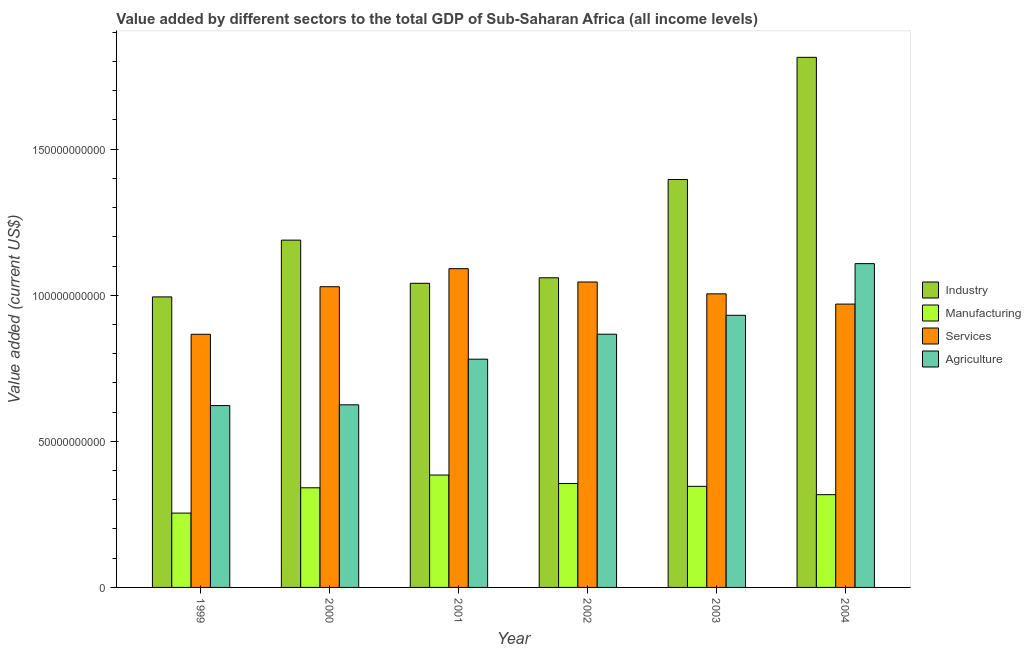How many groups of bars are there?
Your answer should be very brief. 6. Are the number of bars per tick equal to the number of legend labels?
Give a very brief answer. Yes. Are the number of bars on each tick of the X-axis equal?
Provide a succinct answer. Yes. How many bars are there on the 5th tick from the right?
Your answer should be very brief. 4. What is the value added by industrial sector in 1999?
Your response must be concise. 9.94e+1. Across all years, what is the maximum value added by manufacturing sector?
Provide a succinct answer. 3.85e+1. Across all years, what is the minimum value added by industrial sector?
Provide a succinct answer. 9.94e+1. What is the total value added by industrial sector in the graph?
Offer a terse response. 7.49e+11. What is the difference between the value added by services sector in 2000 and that in 2003?
Make the answer very short. 2.44e+09. What is the difference between the value added by services sector in 2002 and the value added by agricultural sector in 1999?
Provide a short and direct response. 1.79e+1. What is the average value added by manufacturing sector per year?
Provide a succinct answer. 3.33e+1. In the year 2004, what is the difference between the value added by agricultural sector and value added by industrial sector?
Offer a terse response. 0. What is the ratio of the value added by services sector in 2000 to that in 2001?
Offer a very short reply. 0.94. Is the difference between the value added by industrial sector in 1999 and 2001 greater than the difference between the value added by agricultural sector in 1999 and 2001?
Ensure brevity in your answer.  No. What is the difference between the highest and the second highest value added by services sector?
Your answer should be compact. 4.56e+09. What is the difference between the highest and the lowest value added by agricultural sector?
Your response must be concise. 4.86e+1. What does the 2nd bar from the left in 2004 represents?
Your response must be concise. Manufacturing. What does the 2nd bar from the right in 2004 represents?
Give a very brief answer. Services. How many bars are there?
Offer a very short reply. 24. How many years are there in the graph?
Make the answer very short. 6. What is the difference between two consecutive major ticks on the Y-axis?
Your answer should be compact. 5.00e+1. Does the graph contain any zero values?
Provide a short and direct response. No. Does the graph contain grids?
Offer a very short reply. No. What is the title of the graph?
Your answer should be compact. Value added by different sectors to the total GDP of Sub-Saharan Africa (all income levels). Does "Overall level" appear as one of the legend labels in the graph?
Provide a succinct answer. No. What is the label or title of the Y-axis?
Provide a succinct answer. Value added (current US$). What is the Value added (current US$) in Industry in 1999?
Your answer should be compact. 9.94e+1. What is the Value added (current US$) of Manufacturing in 1999?
Your response must be concise. 2.54e+1. What is the Value added (current US$) of Services in 1999?
Keep it short and to the point. 8.66e+1. What is the Value added (current US$) in Agriculture in 1999?
Ensure brevity in your answer.  6.22e+1. What is the Value added (current US$) in Industry in 2000?
Your answer should be compact. 1.19e+11. What is the Value added (current US$) of Manufacturing in 2000?
Ensure brevity in your answer.  3.41e+1. What is the Value added (current US$) of Services in 2000?
Keep it short and to the point. 1.03e+11. What is the Value added (current US$) of Agriculture in 2000?
Your answer should be very brief. 6.25e+1. What is the Value added (current US$) of Industry in 2001?
Your answer should be very brief. 1.04e+11. What is the Value added (current US$) of Manufacturing in 2001?
Your answer should be compact. 3.85e+1. What is the Value added (current US$) of Services in 2001?
Your answer should be very brief. 1.09e+11. What is the Value added (current US$) in Agriculture in 2001?
Give a very brief answer. 7.81e+1. What is the Value added (current US$) of Industry in 2002?
Make the answer very short. 1.06e+11. What is the Value added (current US$) of Manufacturing in 2002?
Offer a terse response. 3.56e+1. What is the Value added (current US$) in Services in 2002?
Ensure brevity in your answer.  1.05e+11. What is the Value added (current US$) in Agriculture in 2002?
Offer a very short reply. 8.67e+1. What is the Value added (current US$) of Industry in 2003?
Provide a short and direct response. 1.40e+11. What is the Value added (current US$) of Manufacturing in 2003?
Provide a short and direct response. 3.46e+1. What is the Value added (current US$) in Services in 2003?
Provide a succinct answer. 1.00e+11. What is the Value added (current US$) of Agriculture in 2003?
Make the answer very short. 9.31e+1. What is the Value added (current US$) in Industry in 2004?
Your answer should be very brief. 1.81e+11. What is the Value added (current US$) in Manufacturing in 2004?
Ensure brevity in your answer.  3.17e+1. What is the Value added (current US$) of Services in 2004?
Provide a short and direct response. 9.70e+1. What is the Value added (current US$) of Agriculture in 2004?
Provide a short and direct response. 1.11e+11. Across all years, what is the maximum Value added (current US$) in Industry?
Keep it short and to the point. 1.81e+11. Across all years, what is the maximum Value added (current US$) of Manufacturing?
Make the answer very short. 3.85e+1. Across all years, what is the maximum Value added (current US$) of Services?
Your answer should be very brief. 1.09e+11. Across all years, what is the maximum Value added (current US$) in Agriculture?
Your answer should be very brief. 1.11e+11. Across all years, what is the minimum Value added (current US$) of Industry?
Your answer should be compact. 9.94e+1. Across all years, what is the minimum Value added (current US$) in Manufacturing?
Your response must be concise. 2.54e+1. Across all years, what is the minimum Value added (current US$) in Services?
Offer a very short reply. 8.66e+1. Across all years, what is the minimum Value added (current US$) in Agriculture?
Provide a short and direct response. 6.22e+1. What is the total Value added (current US$) in Industry in the graph?
Offer a very short reply. 7.49e+11. What is the total Value added (current US$) of Manufacturing in the graph?
Offer a very short reply. 2.00e+11. What is the total Value added (current US$) in Services in the graph?
Make the answer very short. 6.01e+11. What is the total Value added (current US$) in Agriculture in the graph?
Give a very brief answer. 4.93e+11. What is the difference between the Value added (current US$) of Industry in 1999 and that in 2000?
Offer a very short reply. -1.94e+1. What is the difference between the Value added (current US$) of Manufacturing in 1999 and that in 2000?
Provide a short and direct response. -8.67e+09. What is the difference between the Value added (current US$) in Services in 1999 and that in 2000?
Keep it short and to the point. -1.63e+1. What is the difference between the Value added (current US$) in Agriculture in 1999 and that in 2000?
Provide a succinct answer. -2.59e+08. What is the difference between the Value added (current US$) in Industry in 1999 and that in 2001?
Your response must be concise. -4.66e+09. What is the difference between the Value added (current US$) in Manufacturing in 1999 and that in 2001?
Keep it short and to the point. -1.30e+1. What is the difference between the Value added (current US$) of Services in 1999 and that in 2001?
Offer a terse response. -2.25e+1. What is the difference between the Value added (current US$) in Agriculture in 1999 and that in 2001?
Your answer should be compact. -1.59e+1. What is the difference between the Value added (current US$) of Industry in 1999 and that in 2002?
Your answer should be very brief. -6.55e+09. What is the difference between the Value added (current US$) in Manufacturing in 1999 and that in 2002?
Your response must be concise. -1.01e+1. What is the difference between the Value added (current US$) in Services in 1999 and that in 2002?
Provide a succinct answer. -1.79e+1. What is the difference between the Value added (current US$) of Agriculture in 1999 and that in 2002?
Your answer should be very brief. -2.44e+1. What is the difference between the Value added (current US$) in Industry in 1999 and that in 2003?
Provide a succinct answer. -4.02e+1. What is the difference between the Value added (current US$) of Manufacturing in 1999 and that in 2003?
Provide a short and direct response. -9.15e+09. What is the difference between the Value added (current US$) in Services in 1999 and that in 2003?
Offer a terse response. -1.38e+1. What is the difference between the Value added (current US$) of Agriculture in 1999 and that in 2003?
Ensure brevity in your answer.  -3.09e+1. What is the difference between the Value added (current US$) in Industry in 1999 and that in 2004?
Offer a terse response. -8.20e+1. What is the difference between the Value added (current US$) in Manufacturing in 1999 and that in 2004?
Provide a short and direct response. -6.31e+09. What is the difference between the Value added (current US$) of Services in 1999 and that in 2004?
Ensure brevity in your answer.  -1.03e+1. What is the difference between the Value added (current US$) in Agriculture in 1999 and that in 2004?
Offer a very short reply. -4.86e+1. What is the difference between the Value added (current US$) of Industry in 2000 and that in 2001?
Make the answer very short. 1.48e+1. What is the difference between the Value added (current US$) in Manufacturing in 2000 and that in 2001?
Provide a succinct answer. -4.36e+09. What is the difference between the Value added (current US$) of Services in 2000 and that in 2001?
Your answer should be compact. -6.18e+09. What is the difference between the Value added (current US$) of Agriculture in 2000 and that in 2001?
Ensure brevity in your answer.  -1.56e+1. What is the difference between the Value added (current US$) of Industry in 2000 and that in 2002?
Make the answer very short. 1.29e+1. What is the difference between the Value added (current US$) of Manufacturing in 2000 and that in 2002?
Provide a short and direct response. -1.48e+09. What is the difference between the Value added (current US$) in Services in 2000 and that in 2002?
Give a very brief answer. -1.62e+09. What is the difference between the Value added (current US$) in Agriculture in 2000 and that in 2002?
Your answer should be compact. -2.42e+1. What is the difference between the Value added (current US$) in Industry in 2000 and that in 2003?
Provide a short and direct response. -2.08e+1. What is the difference between the Value added (current US$) of Manufacturing in 2000 and that in 2003?
Offer a terse response. -4.88e+08. What is the difference between the Value added (current US$) in Services in 2000 and that in 2003?
Offer a terse response. 2.44e+09. What is the difference between the Value added (current US$) of Agriculture in 2000 and that in 2003?
Offer a very short reply. -3.06e+1. What is the difference between the Value added (current US$) in Industry in 2000 and that in 2004?
Your response must be concise. -6.26e+1. What is the difference between the Value added (current US$) in Manufacturing in 2000 and that in 2004?
Your answer should be very brief. 2.35e+09. What is the difference between the Value added (current US$) in Services in 2000 and that in 2004?
Keep it short and to the point. 5.94e+09. What is the difference between the Value added (current US$) in Agriculture in 2000 and that in 2004?
Your answer should be compact. -4.83e+1. What is the difference between the Value added (current US$) in Industry in 2001 and that in 2002?
Make the answer very short. -1.89e+09. What is the difference between the Value added (current US$) of Manufacturing in 2001 and that in 2002?
Your response must be concise. 2.88e+09. What is the difference between the Value added (current US$) of Services in 2001 and that in 2002?
Give a very brief answer. 4.56e+09. What is the difference between the Value added (current US$) of Agriculture in 2001 and that in 2002?
Offer a very short reply. -8.54e+09. What is the difference between the Value added (current US$) in Industry in 2001 and that in 2003?
Ensure brevity in your answer.  -3.55e+1. What is the difference between the Value added (current US$) in Manufacturing in 2001 and that in 2003?
Offer a very short reply. 3.87e+09. What is the difference between the Value added (current US$) in Services in 2001 and that in 2003?
Ensure brevity in your answer.  8.61e+09. What is the difference between the Value added (current US$) in Agriculture in 2001 and that in 2003?
Your response must be concise. -1.50e+1. What is the difference between the Value added (current US$) of Industry in 2001 and that in 2004?
Provide a succinct answer. -7.73e+1. What is the difference between the Value added (current US$) in Manufacturing in 2001 and that in 2004?
Provide a short and direct response. 6.71e+09. What is the difference between the Value added (current US$) in Services in 2001 and that in 2004?
Offer a very short reply. 1.21e+1. What is the difference between the Value added (current US$) in Agriculture in 2001 and that in 2004?
Your response must be concise. -3.27e+1. What is the difference between the Value added (current US$) in Industry in 2002 and that in 2003?
Ensure brevity in your answer.  -3.36e+1. What is the difference between the Value added (current US$) in Manufacturing in 2002 and that in 2003?
Your answer should be compact. 9.88e+08. What is the difference between the Value added (current US$) of Services in 2002 and that in 2003?
Your answer should be compact. 4.06e+09. What is the difference between the Value added (current US$) in Agriculture in 2002 and that in 2003?
Your response must be concise. -6.47e+09. What is the difference between the Value added (current US$) of Industry in 2002 and that in 2004?
Offer a very short reply. -7.54e+1. What is the difference between the Value added (current US$) in Manufacturing in 2002 and that in 2004?
Offer a very short reply. 3.83e+09. What is the difference between the Value added (current US$) of Services in 2002 and that in 2004?
Keep it short and to the point. 7.56e+09. What is the difference between the Value added (current US$) of Agriculture in 2002 and that in 2004?
Your answer should be very brief. -2.42e+1. What is the difference between the Value added (current US$) in Industry in 2003 and that in 2004?
Make the answer very short. -4.18e+1. What is the difference between the Value added (current US$) of Manufacturing in 2003 and that in 2004?
Your answer should be compact. 2.84e+09. What is the difference between the Value added (current US$) in Services in 2003 and that in 2004?
Your answer should be compact. 3.51e+09. What is the difference between the Value added (current US$) in Agriculture in 2003 and that in 2004?
Offer a very short reply. -1.77e+1. What is the difference between the Value added (current US$) in Industry in 1999 and the Value added (current US$) in Manufacturing in 2000?
Your answer should be compact. 6.53e+1. What is the difference between the Value added (current US$) of Industry in 1999 and the Value added (current US$) of Services in 2000?
Offer a very short reply. -3.48e+09. What is the difference between the Value added (current US$) of Industry in 1999 and the Value added (current US$) of Agriculture in 2000?
Provide a succinct answer. 3.69e+1. What is the difference between the Value added (current US$) in Manufacturing in 1999 and the Value added (current US$) in Services in 2000?
Give a very brief answer. -7.75e+1. What is the difference between the Value added (current US$) of Manufacturing in 1999 and the Value added (current US$) of Agriculture in 2000?
Your response must be concise. -3.71e+1. What is the difference between the Value added (current US$) in Services in 1999 and the Value added (current US$) in Agriculture in 2000?
Offer a terse response. 2.41e+1. What is the difference between the Value added (current US$) of Industry in 1999 and the Value added (current US$) of Manufacturing in 2001?
Give a very brief answer. 6.10e+1. What is the difference between the Value added (current US$) of Industry in 1999 and the Value added (current US$) of Services in 2001?
Provide a short and direct response. -9.66e+09. What is the difference between the Value added (current US$) in Industry in 1999 and the Value added (current US$) in Agriculture in 2001?
Keep it short and to the point. 2.13e+1. What is the difference between the Value added (current US$) of Manufacturing in 1999 and the Value added (current US$) of Services in 2001?
Offer a terse response. -8.37e+1. What is the difference between the Value added (current US$) of Manufacturing in 1999 and the Value added (current US$) of Agriculture in 2001?
Your response must be concise. -5.27e+1. What is the difference between the Value added (current US$) of Services in 1999 and the Value added (current US$) of Agriculture in 2001?
Provide a short and direct response. 8.51e+09. What is the difference between the Value added (current US$) of Industry in 1999 and the Value added (current US$) of Manufacturing in 2002?
Keep it short and to the point. 6.38e+1. What is the difference between the Value added (current US$) of Industry in 1999 and the Value added (current US$) of Services in 2002?
Ensure brevity in your answer.  -5.10e+09. What is the difference between the Value added (current US$) of Industry in 1999 and the Value added (current US$) of Agriculture in 2002?
Provide a short and direct response. 1.28e+1. What is the difference between the Value added (current US$) in Manufacturing in 1999 and the Value added (current US$) in Services in 2002?
Ensure brevity in your answer.  -7.91e+1. What is the difference between the Value added (current US$) of Manufacturing in 1999 and the Value added (current US$) of Agriculture in 2002?
Offer a terse response. -6.12e+1. What is the difference between the Value added (current US$) of Services in 1999 and the Value added (current US$) of Agriculture in 2002?
Ensure brevity in your answer.  -2.59e+07. What is the difference between the Value added (current US$) in Industry in 1999 and the Value added (current US$) in Manufacturing in 2003?
Give a very brief answer. 6.48e+1. What is the difference between the Value added (current US$) of Industry in 1999 and the Value added (current US$) of Services in 2003?
Your response must be concise. -1.05e+09. What is the difference between the Value added (current US$) of Industry in 1999 and the Value added (current US$) of Agriculture in 2003?
Ensure brevity in your answer.  6.29e+09. What is the difference between the Value added (current US$) in Manufacturing in 1999 and the Value added (current US$) in Services in 2003?
Your response must be concise. -7.50e+1. What is the difference between the Value added (current US$) in Manufacturing in 1999 and the Value added (current US$) in Agriculture in 2003?
Your answer should be very brief. -6.77e+1. What is the difference between the Value added (current US$) in Services in 1999 and the Value added (current US$) in Agriculture in 2003?
Make the answer very short. -6.50e+09. What is the difference between the Value added (current US$) in Industry in 1999 and the Value added (current US$) in Manufacturing in 2004?
Offer a terse response. 6.77e+1. What is the difference between the Value added (current US$) of Industry in 1999 and the Value added (current US$) of Services in 2004?
Your response must be concise. 2.46e+09. What is the difference between the Value added (current US$) in Industry in 1999 and the Value added (current US$) in Agriculture in 2004?
Make the answer very short. -1.14e+1. What is the difference between the Value added (current US$) of Manufacturing in 1999 and the Value added (current US$) of Services in 2004?
Ensure brevity in your answer.  -7.15e+1. What is the difference between the Value added (current US$) of Manufacturing in 1999 and the Value added (current US$) of Agriculture in 2004?
Your answer should be compact. -8.54e+1. What is the difference between the Value added (current US$) of Services in 1999 and the Value added (current US$) of Agriculture in 2004?
Offer a terse response. -2.42e+1. What is the difference between the Value added (current US$) of Industry in 2000 and the Value added (current US$) of Manufacturing in 2001?
Offer a very short reply. 8.04e+1. What is the difference between the Value added (current US$) in Industry in 2000 and the Value added (current US$) in Services in 2001?
Your answer should be very brief. 9.77e+09. What is the difference between the Value added (current US$) of Industry in 2000 and the Value added (current US$) of Agriculture in 2001?
Keep it short and to the point. 4.07e+1. What is the difference between the Value added (current US$) in Manufacturing in 2000 and the Value added (current US$) in Services in 2001?
Your answer should be very brief. -7.50e+1. What is the difference between the Value added (current US$) of Manufacturing in 2000 and the Value added (current US$) of Agriculture in 2001?
Provide a succinct answer. -4.40e+1. What is the difference between the Value added (current US$) of Services in 2000 and the Value added (current US$) of Agriculture in 2001?
Keep it short and to the point. 2.48e+1. What is the difference between the Value added (current US$) in Industry in 2000 and the Value added (current US$) in Manufacturing in 2002?
Your answer should be compact. 8.33e+1. What is the difference between the Value added (current US$) of Industry in 2000 and the Value added (current US$) of Services in 2002?
Make the answer very short. 1.43e+1. What is the difference between the Value added (current US$) in Industry in 2000 and the Value added (current US$) in Agriculture in 2002?
Keep it short and to the point. 3.22e+1. What is the difference between the Value added (current US$) of Manufacturing in 2000 and the Value added (current US$) of Services in 2002?
Offer a terse response. -7.04e+1. What is the difference between the Value added (current US$) in Manufacturing in 2000 and the Value added (current US$) in Agriculture in 2002?
Ensure brevity in your answer.  -5.26e+1. What is the difference between the Value added (current US$) in Services in 2000 and the Value added (current US$) in Agriculture in 2002?
Make the answer very short. 1.63e+1. What is the difference between the Value added (current US$) in Industry in 2000 and the Value added (current US$) in Manufacturing in 2003?
Your response must be concise. 8.43e+1. What is the difference between the Value added (current US$) of Industry in 2000 and the Value added (current US$) of Services in 2003?
Your answer should be compact. 1.84e+1. What is the difference between the Value added (current US$) in Industry in 2000 and the Value added (current US$) in Agriculture in 2003?
Offer a terse response. 2.57e+1. What is the difference between the Value added (current US$) of Manufacturing in 2000 and the Value added (current US$) of Services in 2003?
Offer a terse response. -6.64e+1. What is the difference between the Value added (current US$) of Manufacturing in 2000 and the Value added (current US$) of Agriculture in 2003?
Offer a terse response. -5.90e+1. What is the difference between the Value added (current US$) in Services in 2000 and the Value added (current US$) in Agriculture in 2003?
Ensure brevity in your answer.  9.78e+09. What is the difference between the Value added (current US$) of Industry in 2000 and the Value added (current US$) of Manufacturing in 2004?
Give a very brief answer. 8.71e+1. What is the difference between the Value added (current US$) in Industry in 2000 and the Value added (current US$) in Services in 2004?
Make the answer very short. 2.19e+1. What is the difference between the Value added (current US$) in Industry in 2000 and the Value added (current US$) in Agriculture in 2004?
Provide a short and direct response. 8.04e+09. What is the difference between the Value added (current US$) in Manufacturing in 2000 and the Value added (current US$) in Services in 2004?
Provide a short and direct response. -6.29e+1. What is the difference between the Value added (current US$) of Manufacturing in 2000 and the Value added (current US$) of Agriculture in 2004?
Provide a short and direct response. -7.67e+1. What is the difference between the Value added (current US$) of Services in 2000 and the Value added (current US$) of Agriculture in 2004?
Offer a terse response. -7.90e+09. What is the difference between the Value added (current US$) in Industry in 2001 and the Value added (current US$) in Manufacturing in 2002?
Your answer should be very brief. 6.85e+1. What is the difference between the Value added (current US$) in Industry in 2001 and the Value added (current US$) in Services in 2002?
Your response must be concise. -4.41e+08. What is the difference between the Value added (current US$) of Industry in 2001 and the Value added (current US$) of Agriculture in 2002?
Provide a succinct answer. 1.74e+1. What is the difference between the Value added (current US$) of Manufacturing in 2001 and the Value added (current US$) of Services in 2002?
Give a very brief answer. -6.61e+1. What is the difference between the Value added (current US$) in Manufacturing in 2001 and the Value added (current US$) in Agriculture in 2002?
Provide a succinct answer. -4.82e+1. What is the difference between the Value added (current US$) in Services in 2001 and the Value added (current US$) in Agriculture in 2002?
Make the answer very short. 2.24e+1. What is the difference between the Value added (current US$) in Industry in 2001 and the Value added (current US$) in Manufacturing in 2003?
Offer a terse response. 6.95e+1. What is the difference between the Value added (current US$) in Industry in 2001 and the Value added (current US$) in Services in 2003?
Ensure brevity in your answer.  3.61e+09. What is the difference between the Value added (current US$) of Industry in 2001 and the Value added (current US$) of Agriculture in 2003?
Your answer should be compact. 1.10e+1. What is the difference between the Value added (current US$) in Manufacturing in 2001 and the Value added (current US$) in Services in 2003?
Your answer should be very brief. -6.20e+1. What is the difference between the Value added (current US$) of Manufacturing in 2001 and the Value added (current US$) of Agriculture in 2003?
Ensure brevity in your answer.  -5.47e+1. What is the difference between the Value added (current US$) of Services in 2001 and the Value added (current US$) of Agriculture in 2003?
Your answer should be very brief. 1.60e+1. What is the difference between the Value added (current US$) of Industry in 2001 and the Value added (current US$) of Manufacturing in 2004?
Your response must be concise. 7.23e+1. What is the difference between the Value added (current US$) of Industry in 2001 and the Value added (current US$) of Services in 2004?
Offer a very short reply. 7.12e+09. What is the difference between the Value added (current US$) of Industry in 2001 and the Value added (current US$) of Agriculture in 2004?
Offer a very short reply. -6.73e+09. What is the difference between the Value added (current US$) in Manufacturing in 2001 and the Value added (current US$) in Services in 2004?
Keep it short and to the point. -5.85e+1. What is the difference between the Value added (current US$) in Manufacturing in 2001 and the Value added (current US$) in Agriculture in 2004?
Your answer should be very brief. -7.24e+1. What is the difference between the Value added (current US$) in Services in 2001 and the Value added (current US$) in Agriculture in 2004?
Offer a terse response. -1.73e+09. What is the difference between the Value added (current US$) in Industry in 2002 and the Value added (current US$) in Manufacturing in 2003?
Keep it short and to the point. 7.14e+1. What is the difference between the Value added (current US$) in Industry in 2002 and the Value added (current US$) in Services in 2003?
Offer a very short reply. 5.50e+09. What is the difference between the Value added (current US$) in Industry in 2002 and the Value added (current US$) in Agriculture in 2003?
Ensure brevity in your answer.  1.28e+1. What is the difference between the Value added (current US$) in Manufacturing in 2002 and the Value added (current US$) in Services in 2003?
Your answer should be compact. -6.49e+1. What is the difference between the Value added (current US$) of Manufacturing in 2002 and the Value added (current US$) of Agriculture in 2003?
Keep it short and to the point. -5.76e+1. What is the difference between the Value added (current US$) of Services in 2002 and the Value added (current US$) of Agriculture in 2003?
Give a very brief answer. 1.14e+1. What is the difference between the Value added (current US$) in Industry in 2002 and the Value added (current US$) in Manufacturing in 2004?
Keep it short and to the point. 7.42e+1. What is the difference between the Value added (current US$) of Industry in 2002 and the Value added (current US$) of Services in 2004?
Make the answer very short. 9.01e+09. What is the difference between the Value added (current US$) of Industry in 2002 and the Value added (current US$) of Agriculture in 2004?
Give a very brief answer. -4.84e+09. What is the difference between the Value added (current US$) in Manufacturing in 2002 and the Value added (current US$) in Services in 2004?
Your response must be concise. -6.14e+1. What is the difference between the Value added (current US$) of Manufacturing in 2002 and the Value added (current US$) of Agriculture in 2004?
Ensure brevity in your answer.  -7.52e+1. What is the difference between the Value added (current US$) of Services in 2002 and the Value added (current US$) of Agriculture in 2004?
Your answer should be compact. -6.29e+09. What is the difference between the Value added (current US$) of Industry in 2003 and the Value added (current US$) of Manufacturing in 2004?
Provide a succinct answer. 1.08e+11. What is the difference between the Value added (current US$) in Industry in 2003 and the Value added (current US$) in Services in 2004?
Provide a short and direct response. 4.26e+1. What is the difference between the Value added (current US$) of Industry in 2003 and the Value added (current US$) of Agriculture in 2004?
Your answer should be compact. 2.88e+1. What is the difference between the Value added (current US$) of Manufacturing in 2003 and the Value added (current US$) of Services in 2004?
Your response must be concise. -6.24e+1. What is the difference between the Value added (current US$) of Manufacturing in 2003 and the Value added (current US$) of Agriculture in 2004?
Make the answer very short. -7.62e+1. What is the difference between the Value added (current US$) of Services in 2003 and the Value added (current US$) of Agriculture in 2004?
Offer a terse response. -1.03e+1. What is the average Value added (current US$) in Industry per year?
Your answer should be very brief. 1.25e+11. What is the average Value added (current US$) in Manufacturing per year?
Ensure brevity in your answer.  3.33e+1. What is the average Value added (current US$) in Services per year?
Provide a succinct answer. 1.00e+11. What is the average Value added (current US$) of Agriculture per year?
Give a very brief answer. 8.22e+1. In the year 1999, what is the difference between the Value added (current US$) in Industry and Value added (current US$) in Manufacturing?
Your answer should be compact. 7.40e+1. In the year 1999, what is the difference between the Value added (current US$) of Industry and Value added (current US$) of Services?
Give a very brief answer. 1.28e+1. In the year 1999, what is the difference between the Value added (current US$) of Industry and Value added (current US$) of Agriculture?
Ensure brevity in your answer.  3.72e+1. In the year 1999, what is the difference between the Value added (current US$) in Manufacturing and Value added (current US$) in Services?
Give a very brief answer. -6.12e+1. In the year 1999, what is the difference between the Value added (current US$) in Manufacturing and Value added (current US$) in Agriculture?
Make the answer very short. -3.68e+1. In the year 1999, what is the difference between the Value added (current US$) in Services and Value added (current US$) in Agriculture?
Provide a short and direct response. 2.44e+1. In the year 2000, what is the difference between the Value added (current US$) of Industry and Value added (current US$) of Manufacturing?
Ensure brevity in your answer.  8.48e+1. In the year 2000, what is the difference between the Value added (current US$) in Industry and Value added (current US$) in Services?
Provide a succinct answer. 1.59e+1. In the year 2000, what is the difference between the Value added (current US$) in Industry and Value added (current US$) in Agriculture?
Make the answer very short. 5.64e+1. In the year 2000, what is the difference between the Value added (current US$) in Manufacturing and Value added (current US$) in Services?
Your answer should be very brief. -6.88e+1. In the year 2000, what is the difference between the Value added (current US$) in Manufacturing and Value added (current US$) in Agriculture?
Ensure brevity in your answer.  -2.84e+1. In the year 2000, what is the difference between the Value added (current US$) in Services and Value added (current US$) in Agriculture?
Keep it short and to the point. 4.04e+1. In the year 2001, what is the difference between the Value added (current US$) of Industry and Value added (current US$) of Manufacturing?
Give a very brief answer. 6.56e+1. In the year 2001, what is the difference between the Value added (current US$) of Industry and Value added (current US$) of Services?
Provide a short and direct response. -5.00e+09. In the year 2001, what is the difference between the Value added (current US$) of Industry and Value added (current US$) of Agriculture?
Your answer should be very brief. 2.60e+1. In the year 2001, what is the difference between the Value added (current US$) in Manufacturing and Value added (current US$) in Services?
Offer a terse response. -7.06e+1. In the year 2001, what is the difference between the Value added (current US$) in Manufacturing and Value added (current US$) in Agriculture?
Your response must be concise. -3.97e+1. In the year 2001, what is the difference between the Value added (current US$) of Services and Value added (current US$) of Agriculture?
Offer a terse response. 3.10e+1. In the year 2002, what is the difference between the Value added (current US$) in Industry and Value added (current US$) in Manufacturing?
Your answer should be very brief. 7.04e+1. In the year 2002, what is the difference between the Value added (current US$) of Industry and Value added (current US$) of Services?
Your answer should be compact. 1.44e+09. In the year 2002, what is the difference between the Value added (current US$) in Industry and Value added (current US$) in Agriculture?
Offer a very short reply. 1.93e+1. In the year 2002, what is the difference between the Value added (current US$) in Manufacturing and Value added (current US$) in Services?
Keep it short and to the point. -6.90e+1. In the year 2002, what is the difference between the Value added (current US$) of Manufacturing and Value added (current US$) of Agriculture?
Your answer should be compact. -5.11e+1. In the year 2002, what is the difference between the Value added (current US$) of Services and Value added (current US$) of Agriculture?
Provide a succinct answer. 1.79e+1. In the year 2003, what is the difference between the Value added (current US$) in Industry and Value added (current US$) in Manufacturing?
Your answer should be compact. 1.05e+11. In the year 2003, what is the difference between the Value added (current US$) of Industry and Value added (current US$) of Services?
Keep it short and to the point. 3.91e+1. In the year 2003, what is the difference between the Value added (current US$) in Industry and Value added (current US$) in Agriculture?
Provide a short and direct response. 4.65e+1. In the year 2003, what is the difference between the Value added (current US$) in Manufacturing and Value added (current US$) in Services?
Offer a terse response. -6.59e+1. In the year 2003, what is the difference between the Value added (current US$) in Manufacturing and Value added (current US$) in Agriculture?
Offer a terse response. -5.85e+1. In the year 2003, what is the difference between the Value added (current US$) in Services and Value added (current US$) in Agriculture?
Offer a terse response. 7.34e+09. In the year 2004, what is the difference between the Value added (current US$) of Industry and Value added (current US$) of Manufacturing?
Provide a succinct answer. 1.50e+11. In the year 2004, what is the difference between the Value added (current US$) in Industry and Value added (current US$) in Services?
Your answer should be compact. 8.45e+1. In the year 2004, what is the difference between the Value added (current US$) in Industry and Value added (current US$) in Agriculture?
Offer a very short reply. 7.06e+1. In the year 2004, what is the difference between the Value added (current US$) in Manufacturing and Value added (current US$) in Services?
Ensure brevity in your answer.  -6.52e+1. In the year 2004, what is the difference between the Value added (current US$) in Manufacturing and Value added (current US$) in Agriculture?
Offer a very short reply. -7.91e+1. In the year 2004, what is the difference between the Value added (current US$) of Services and Value added (current US$) of Agriculture?
Provide a short and direct response. -1.38e+1. What is the ratio of the Value added (current US$) in Industry in 1999 to that in 2000?
Provide a short and direct response. 0.84. What is the ratio of the Value added (current US$) in Manufacturing in 1999 to that in 2000?
Make the answer very short. 0.75. What is the ratio of the Value added (current US$) of Services in 1999 to that in 2000?
Ensure brevity in your answer.  0.84. What is the ratio of the Value added (current US$) of Agriculture in 1999 to that in 2000?
Offer a very short reply. 1. What is the ratio of the Value added (current US$) in Industry in 1999 to that in 2001?
Your response must be concise. 0.96. What is the ratio of the Value added (current US$) of Manufacturing in 1999 to that in 2001?
Ensure brevity in your answer.  0.66. What is the ratio of the Value added (current US$) of Services in 1999 to that in 2001?
Ensure brevity in your answer.  0.79. What is the ratio of the Value added (current US$) in Agriculture in 1999 to that in 2001?
Ensure brevity in your answer.  0.8. What is the ratio of the Value added (current US$) in Industry in 1999 to that in 2002?
Give a very brief answer. 0.94. What is the ratio of the Value added (current US$) of Manufacturing in 1999 to that in 2002?
Make the answer very short. 0.71. What is the ratio of the Value added (current US$) of Services in 1999 to that in 2002?
Provide a short and direct response. 0.83. What is the ratio of the Value added (current US$) in Agriculture in 1999 to that in 2002?
Offer a terse response. 0.72. What is the ratio of the Value added (current US$) in Industry in 1999 to that in 2003?
Your answer should be compact. 0.71. What is the ratio of the Value added (current US$) of Manufacturing in 1999 to that in 2003?
Ensure brevity in your answer.  0.74. What is the ratio of the Value added (current US$) in Services in 1999 to that in 2003?
Provide a succinct answer. 0.86. What is the ratio of the Value added (current US$) in Agriculture in 1999 to that in 2003?
Provide a succinct answer. 0.67. What is the ratio of the Value added (current US$) in Industry in 1999 to that in 2004?
Your answer should be compact. 0.55. What is the ratio of the Value added (current US$) in Manufacturing in 1999 to that in 2004?
Provide a succinct answer. 0.8. What is the ratio of the Value added (current US$) in Services in 1999 to that in 2004?
Offer a terse response. 0.89. What is the ratio of the Value added (current US$) in Agriculture in 1999 to that in 2004?
Make the answer very short. 0.56. What is the ratio of the Value added (current US$) of Industry in 2000 to that in 2001?
Offer a very short reply. 1.14. What is the ratio of the Value added (current US$) of Manufacturing in 2000 to that in 2001?
Your answer should be compact. 0.89. What is the ratio of the Value added (current US$) in Services in 2000 to that in 2001?
Your response must be concise. 0.94. What is the ratio of the Value added (current US$) of Agriculture in 2000 to that in 2001?
Your response must be concise. 0.8. What is the ratio of the Value added (current US$) in Industry in 2000 to that in 2002?
Provide a short and direct response. 1.12. What is the ratio of the Value added (current US$) in Manufacturing in 2000 to that in 2002?
Your response must be concise. 0.96. What is the ratio of the Value added (current US$) in Services in 2000 to that in 2002?
Your answer should be very brief. 0.98. What is the ratio of the Value added (current US$) of Agriculture in 2000 to that in 2002?
Offer a very short reply. 0.72. What is the ratio of the Value added (current US$) in Industry in 2000 to that in 2003?
Your answer should be very brief. 0.85. What is the ratio of the Value added (current US$) in Manufacturing in 2000 to that in 2003?
Ensure brevity in your answer.  0.99. What is the ratio of the Value added (current US$) in Services in 2000 to that in 2003?
Provide a short and direct response. 1.02. What is the ratio of the Value added (current US$) of Agriculture in 2000 to that in 2003?
Provide a succinct answer. 0.67. What is the ratio of the Value added (current US$) in Industry in 2000 to that in 2004?
Provide a short and direct response. 0.66. What is the ratio of the Value added (current US$) of Manufacturing in 2000 to that in 2004?
Your answer should be very brief. 1.07. What is the ratio of the Value added (current US$) in Services in 2000 to that in 2004?
Your response must be concise. 1.06. What is the ratio of the Value added (current US$) in Agriculture in 2000 to that in 2004?
Provide a short and direct response. 0.56. What is the ratio of the Value added (current US$) of Industry in 2001 to that in 2002?
Ensure brevity in your answer.  0.98. What is the ratio of the Value added (current US$) in Manufacturing in 2001 to that in 2002?
Keep it short and to the point. 1.08. What is the ratio of the Value added (current US$) in Services in 2001 to that in 2002?
Your response must be concise. 1.04. What is the ratio of the Value added (current US$) in Agriculture in 2001 to that in 2002?
Your response must be concise. 0.9. What is the ratio of the Value added (current US$) in Industry in 2001 to that in 2003?
Make the answer very short. 0.75. What is the ratio of the Value added (current US$) in Manufacturing in 2001 to that in 2003?
Provide a short and direct response. 1.11. What is the ratio of the Value added (current US$) of Services in 2001 to that in 2003?
Give a very brief answer. 1.09. What is the ratio of the Value added (current US$) in Agriculture in 2001 to that in 2003?
Keep it short and to the point. 0.84. What is the ratio of the Value added (current US$) in Industry in 2001 to that in 2004?
Your response must be concise. 0.57. What is the ratio of the Value added (current US$) in Manufacturing in 2001 to that in 2004?
Make the answer very short. 1.21. What is the ratio of the Value added (current US$) in Services in 2001 to that in 2004?
Ensure brevity in your answer.  1.12. What is the ratio of the Value added (current US$) of Agriculture in 2001 to that in 2004?
Offer a terse response. 0.7. What is the ratio of the Value added (current US$) in Industry in 2002 to that in 2003?
Make the answer very short. 0.76. What is the ratio of the Value added (current US$) in Manufacturing in 2002 to that in 2003?
Your answer should be very brief. 1.03. What is the ratio of the Value added (current US$) of Services in 2002 to that in 2003?
Give a very brief answer. 1.04. What is the ratio of the Value added (current US$) in Agriculture in 2002 to that in 2003?
Your response must be concise. 0.93. What is the ratio of the Value added (current US$) in Industry in 2002 to that in 2004?
Make the answer very short. 0.58. What is the ratio of the Value added (current US$) in Manufacturing in 2002 to that in 2004?
Give a very brief answer. 1.12. What is the ratio of the Value added (current US$) of Services in 2002 to that in 2004?
Offer a very short reply. 1.08. What is the ratio of the Value added (current US$) in Agriculture in 2002 to that in 2004?
Ensure brevity in your answer.  0.78. What is the ratio of the Value added (current US$) of Industry in 2003 to that in 2004?
Give a very brief answer. 0.77. What is the ratio of the Value added (current US$) of Manufacturing in 2003 to that in 2004?
Your response must be concise. 1.09. What is the ratio of the Value added (current US$) in Services in 2003 to that in 2004?
Make the answer very short. 1.04. What is the ratio of the Value added (current US$) of Agriculture in 2003 to that in 2004?
Your answer should be compact. 0.84. What is the difference between the highest and the second highest Value added (current US$) in Industry?
Give a very brief answer. 4.18e+1. What is the difference between the highest and the second highest Value added (current US$) of Manufacturing?
Offer a very short reply. 2.88e+09. What is the difference between the highest and the second highest Value added (current US$) of Services?
Keep it short and to the point. 4.56e+09. What is the difference between the highest and the second highest Value added (current US$) of Agriculture?
Your response must be concise. 1.77e+1. What is the difference between the highest and the lowest Value added (current US$) of Industry?
Offer a terse response. 8.20e+1. What is the difference between the highest and the lowest Value added (current US$) of Manufacturing?
Provide a succinct answer. 1.30e+1. What is the difference between the highest and the lowest Value added (current US$) in Services?
Offer a terse response. 2.25e+1. What is the difference between the highest and the lowest Value added (current US$) in Agriculture?
Your answer should be compact. 4.86e+1. 